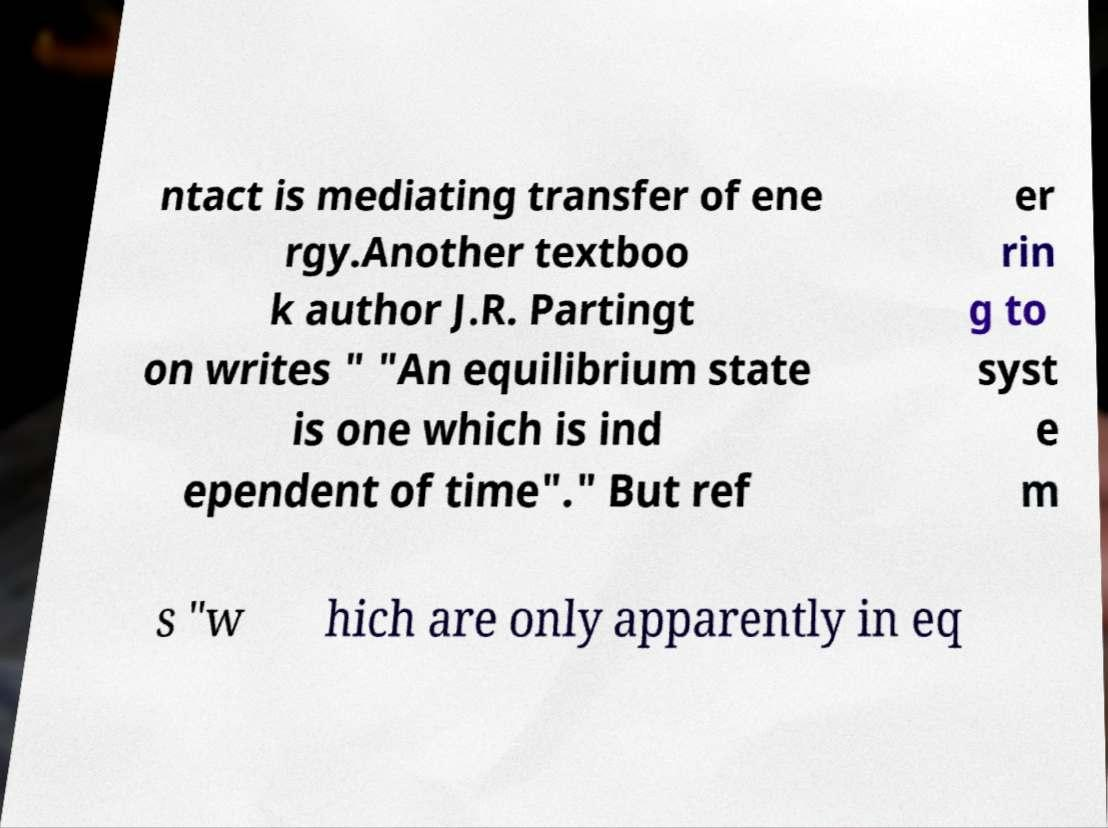I need the written content from this picture converted into text. Can you do that? ntact is mediating transfer of ene rgy.Another textboo k author J.R. Partingt on writes " "An equilibrium state is one which is ind ependent of time"." But ref er rin g to syst e m s "w hich are only apparently in eq 